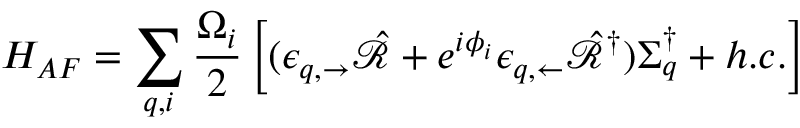<formula> <loc_0><loc_0><loc_500><loc_500>H _ { A F } = \sum _ { q , i } \frac { \Omega _ { i } } { 2 } \left [ ( \epsilon _ { q , \rightarrow } \hat { \mathcal { R } } + e ^ { i \phi _ { i } } \epsilon _ { q , \leftarrow } \hat { \mathcal { R } } ^ { \dag } ) \Sigma _ { q } ^ { \dag } + h . c . \right ]</formula> 